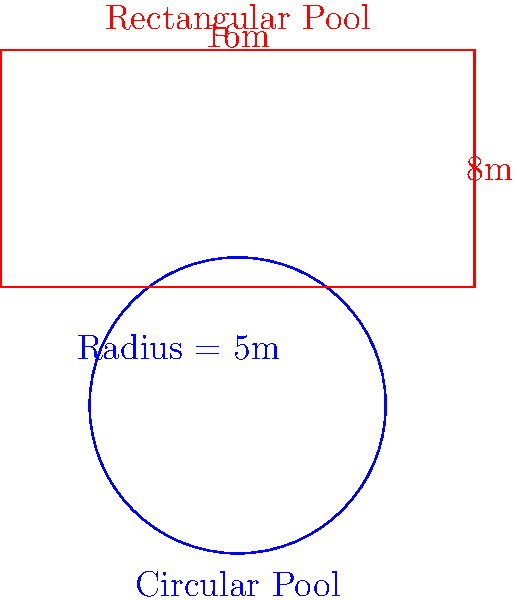As an insurance attorney assessing liability for swimming pool accidents, you're comparing two properties: one with a circular pool (radius 5m) and another with a rectangular pool (16m x 8m). Which pool has a larger surface area, and by how much? Express the difference as a percentage of the smaller area. Let's approach this step-by-step:

1. Calculate the area of the circular pool:
   $A_c = \pi r^2 = \pi (5\text{m})^2 = 25\pi \text{ m}^2 \approx 78.54 \text{ m}^2$

2. Calculate the area of the rectangular pool:
   $A_r = l \times w = 16\text{m} \times 8\text{m} = 128 \text{ m}^2$

3. Compare the areas:
   The rectangular pool has a larger area.

4. Calculate the difference in area:
   $\text{Difference} = 128 \text{ m}^2 - 78.54 \text{ m}^2 = 49.46 \text{ m}^2$

5. Express the difference as a percentage of the smaller area:
   $\text{Percentage difference} = \frac{49.46 \text{ m}^2}{78.54 \text{ m}^2} \times 100\% \approx 62.97\%$

Therefore, the rectangular pool has a larger surface area, and the difference is approximately 62.97% of the circular pool's area.
Answer: Rectangular pool; 62.97% larger 